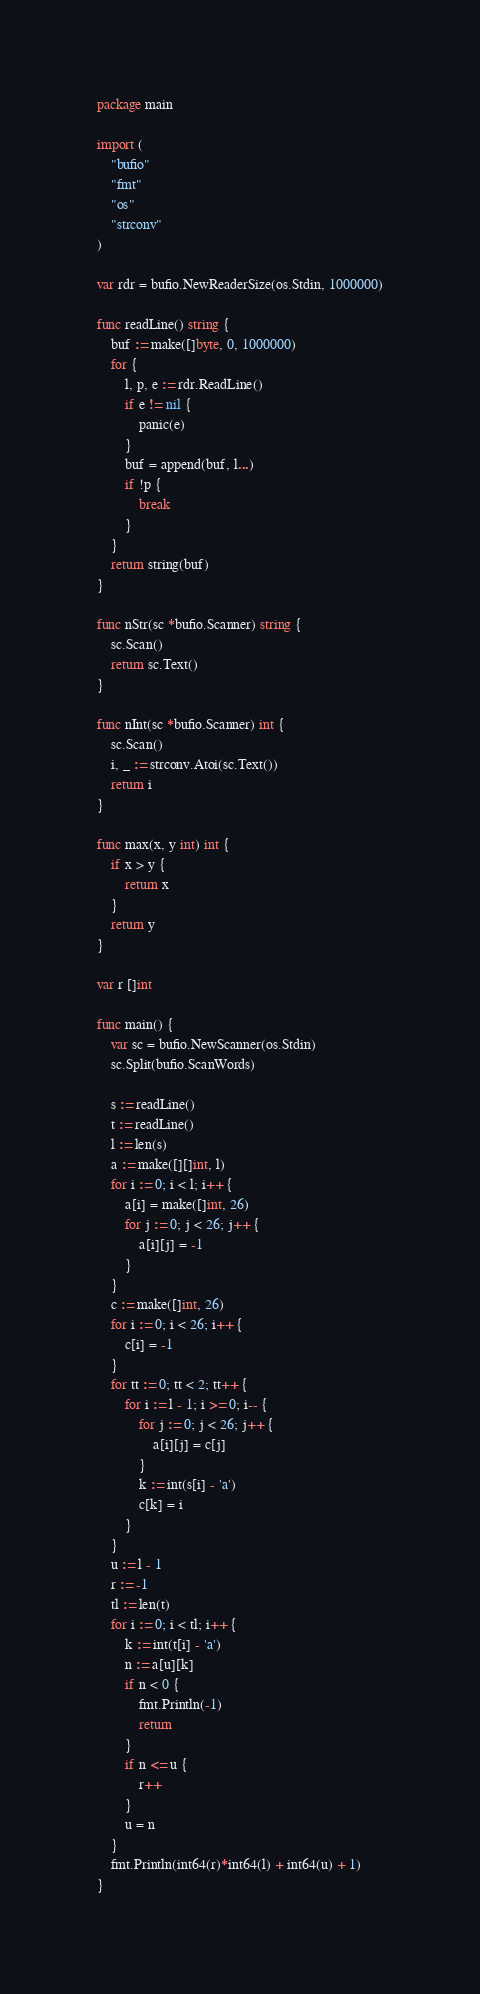<code> <loc_0><loc_0><loc_500><loc_500><_Go_>package main

import (
	"bufio"
	"fmt"
	"os"
	"strconv"
)

var rdr = bufio.NewReaderSize(os.Stdin, 1000000)

func readLine() string {
	buf := make([]byte, 0, 1000000)
	for {
		l, p, e := rdr.ReadLine()
		if e != nil {
			panic(e)
		}
		buf = append(buf, l...)
		if !p {
			break
		}
	}
	return string(buf)
}

func nStr(sc *bufio.Scanner) string {
	sc.Scan()
	return sc.Text()
}

func nInt(sc *bufio.Scanner) int {
	sc.Scan()
	i, _ := strconv.Atoi(sc.Text())
	return i
}

func max(x, y int) int {
	if x > y {
		return x
	}
	return y
}

var r []int

func main() {
	var sc = bufio.NewScanner(os.Stdin)
	sc.Split(bufio.ScanWords)

	s := readLine()
	t := readLine()
	l := len(s)
	a := make([][]int, l)
	for i := 0; i < l; i++ {
		a[i] = make([]int, 26)
		for j := 0; j < 26; j++ {
			a[i][j] = -1
		}
	}
	c := make([]int, 26)
	for i := 0; i < 26; i++ {
		c[i] = -1
	}
	for tt := 0; tt < 2; tt++ {
		for i := l - 1; i >= 0; i-- {
			for j := 0; j < 26; j++ {
				a[i][j] = c[j]
			}
			k := int(s[i] - 'a')
			c[k] = i
		}
	}
	u := l - 1
	r := -1
	tl := len(t)
	for i := 0; i < tl; i++ {
		k := int(t[i] - 'a')
		n := a[u][k]
		if n < 0 {
			fmt.Println(-1)
			return
		}
		if n <= u {
			r++
		}
		u = n
	}
	fmt.Println(int64(r)*int64(l) + int64(u) + 1)
}
</code> 